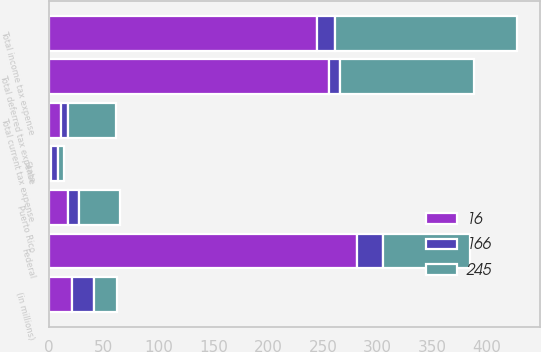Convert chart to OTSL. <chart><loc_0><loc_0><loc_500><loc_500><stacked_bar_chart><ecel><fcel>(in millions)<fcel>State<fcel>Puerto Rico<fcel>Total current tax expense<fcel>Federal<fcel>Total deferred tax expense<fcel>Total income tax expense<nl><fcel>16<fcel>20.5<fcel>2<fcel>17<fcel>11<fcel>281<fcel>256<fcel>245<nl><fcel>245<fcel>20.5<fcel>6<fcel>38<fcel>44<fcel>79<fcel>122<fcel>166<nl><fcel>166<fcel>20.5<fcel>6<fcel>10<fcel>6<fcel>24<fcel>10<fcel>16<nl></chart> 